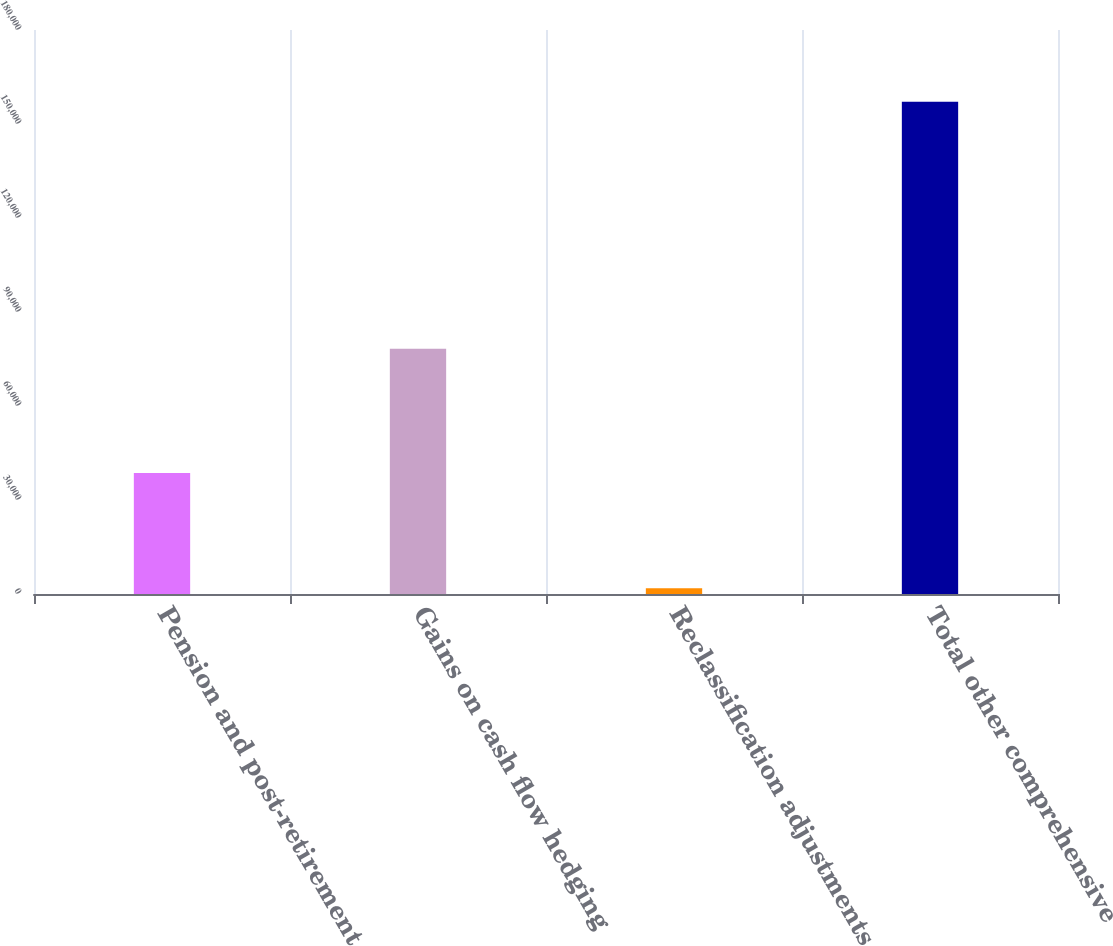Convert chart to OTSL. <chart><loc_0><loc_0><loc_500><loc_500><bar_chart><fcel>Pension and post-retirement<fcel>Gains on cash flow hedging<fcel>Reclassification adjustments<fcel>Total other comprehensive<nl><fcel>38643<fcel>78257<fcel>1862<fcel>157064<nl></chart> 